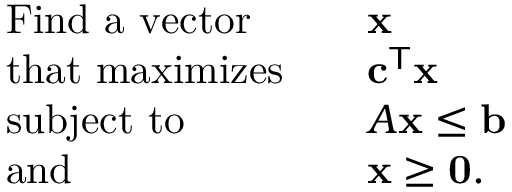<formula> <loc_0><loc_0><loc_500><loc_500>{ \begin{array} { r l r l } & { F i n d a v e c t o r } & & { x } \\ & { t h a t \max i m i z e s } & & { c ^ { T } x } \\ & { s u b j e c t t o } & & { A x \leq b } \\ & { a n d } & & { x \geq 0 . } \end{array} }</formula> 